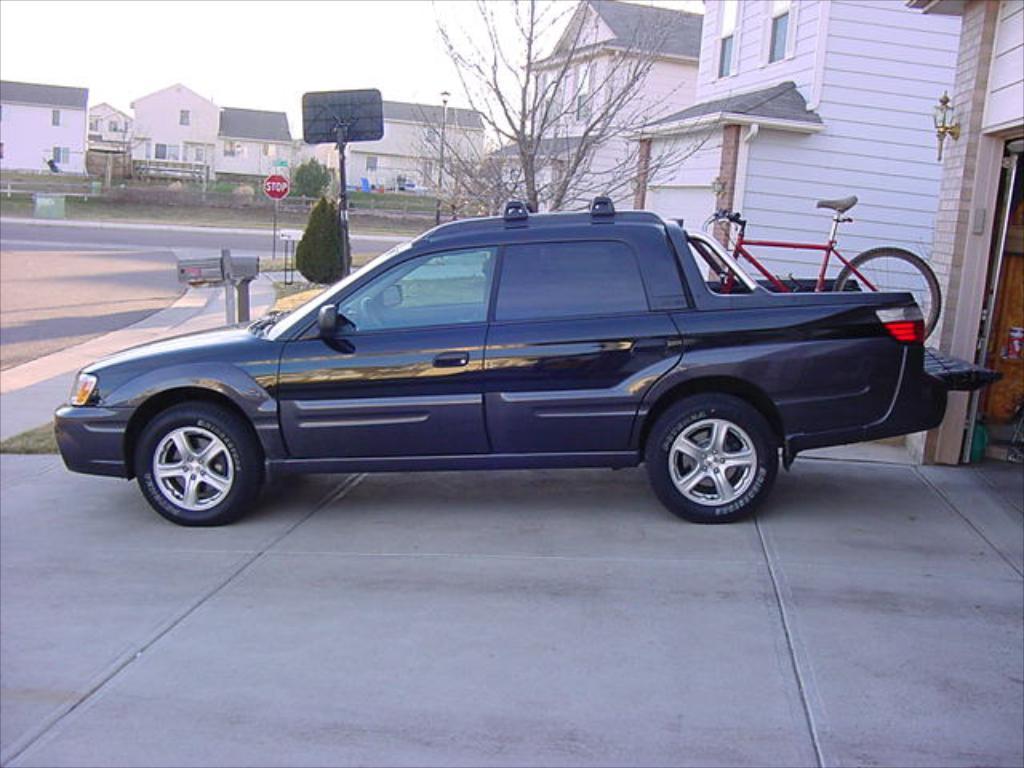How would you summarize this image in a sentence or two? In this image we can see one car is parked. Background of the image buildings and poles are there. Behind the car tree is present. Left side of the image road is there and back of the car one red color bicycle is kept. 